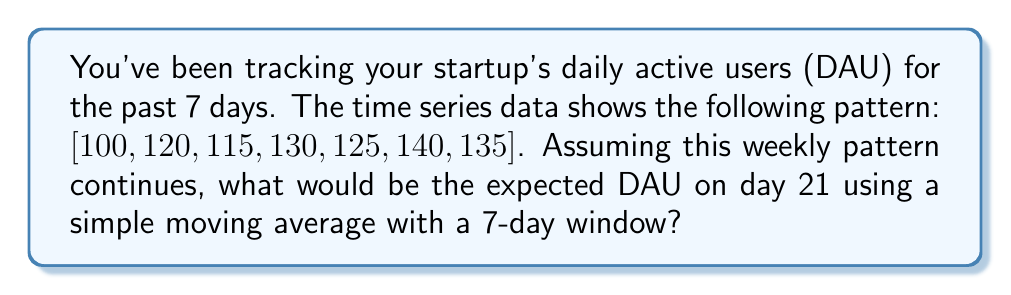Give your solution to this math problem. To solve this problem, we'll use a simple moving average (SMA) with a 7-day window to predict the DAU on day 21. Here's the step-by-step process:

1. First, we need to calculate the SMA for the given 7 days:
   $$ SMA = \frac{100 + 120 + 115 + 130 + 125 + 140 + 135}{7} = \frac{865}{7} = 123.57 $$

2. Assuming the weekly pattern continues, we can extend the series for the next two weeks:
   Week 2: [140, 135, 100, 120, 115, 130, 125]
   Week 3: [140, 135, 100, 120, 115, 130, 125]

3. To find the DAU on day 21, we need to calculate the 7-day SMA for the last 7 days up to day 21:
   $$ SMA_{day21} = \frac{135 + 100 + 120 + 115 + 130 + 125 + 140}{7} = \frac{865}{7} = 123.57 $$

4. The expected DAU on day 21 is the same as the initial SMA because the weekly pattern repeats exactly.

Therefore, the expected DAU on day 21 using a 7-day simple moving average is 123.57, which we can round to 124 users for practical purposes.
Answer: 124 users 